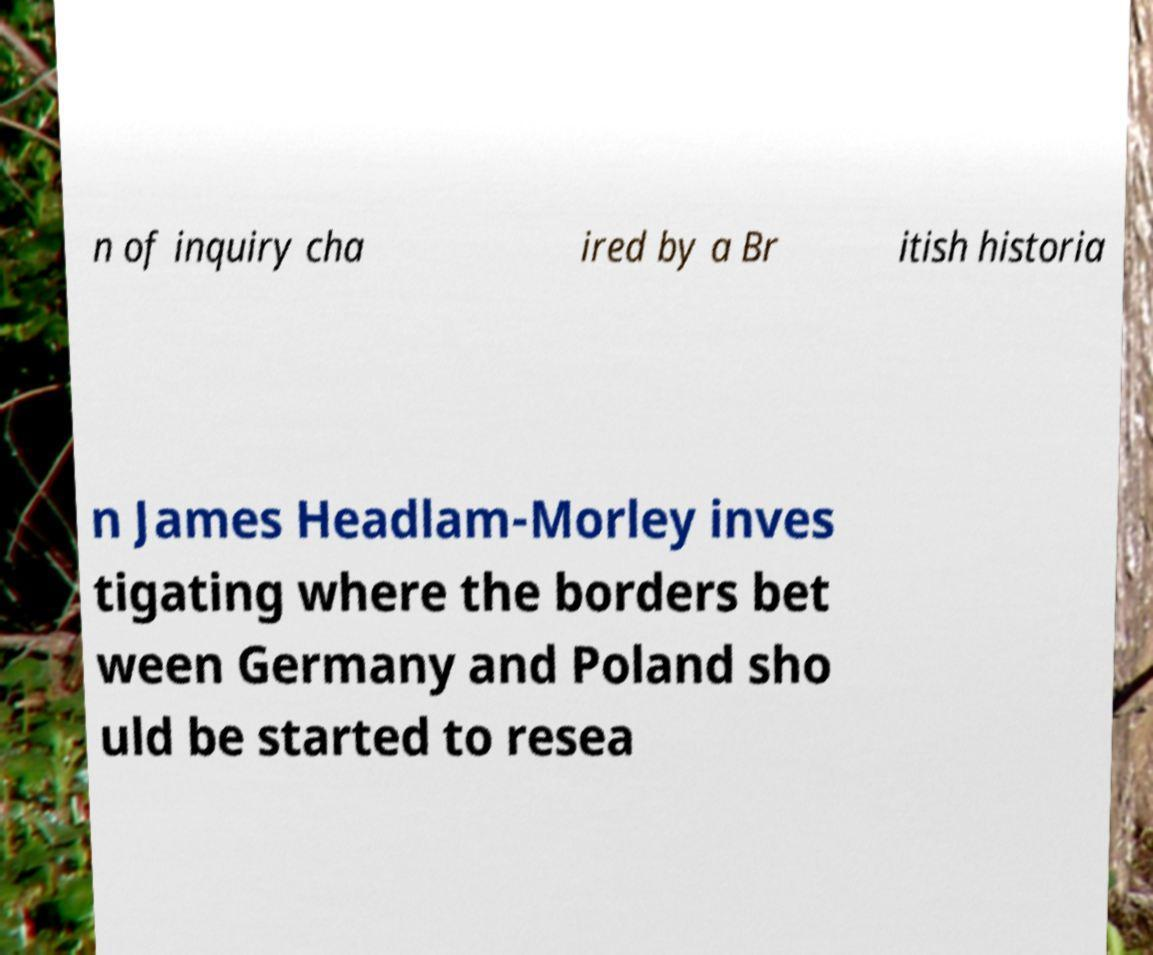Please read and relay the text visible in this image. What does it say? n of inquiry cha ired by a Br itish historia n James Headlam-Morley inves tigating where the borders bet ween Germany and Poland sho uld be started to resea 